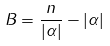<formula> <loc_0><loc_0><loc_500><loc_500>B = \frac { n } { | \alpha | } - | \alpha |</formula> 